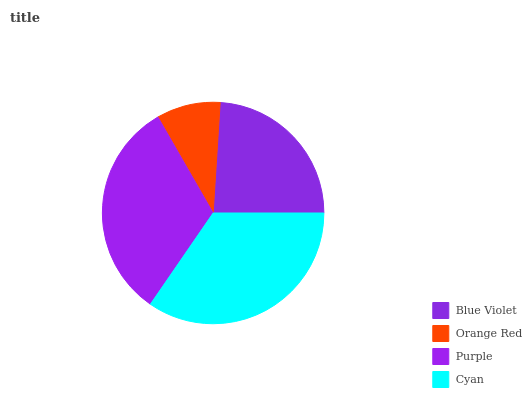Is Orange Red the minimum?
Answer yes or no. Yes. Is Cyan the maximum?
Answer yes or no. Yes. Is Purple the minimum?
Answer yes or no. No. Is Purple the maximum?
Answer yes or no. No. Is Purple greater than Orange Red?
Answer yes or no. Yes. Is Orange Red less than Purple?
Answer yes or no. Yes. Is Orange Red greater than Purple?
Answer yes or no. No. Is Purple less than Orange Red?
Answer yes or no. No. Is Purple the high median?
Answer yes or no. Yes. Is Blue Violet the low median?
Answer yes or no. Yes. Is Orange Red the high median?
Answer yes or no. No. Is Orange Red the low median?
Answer yes or no. No. 